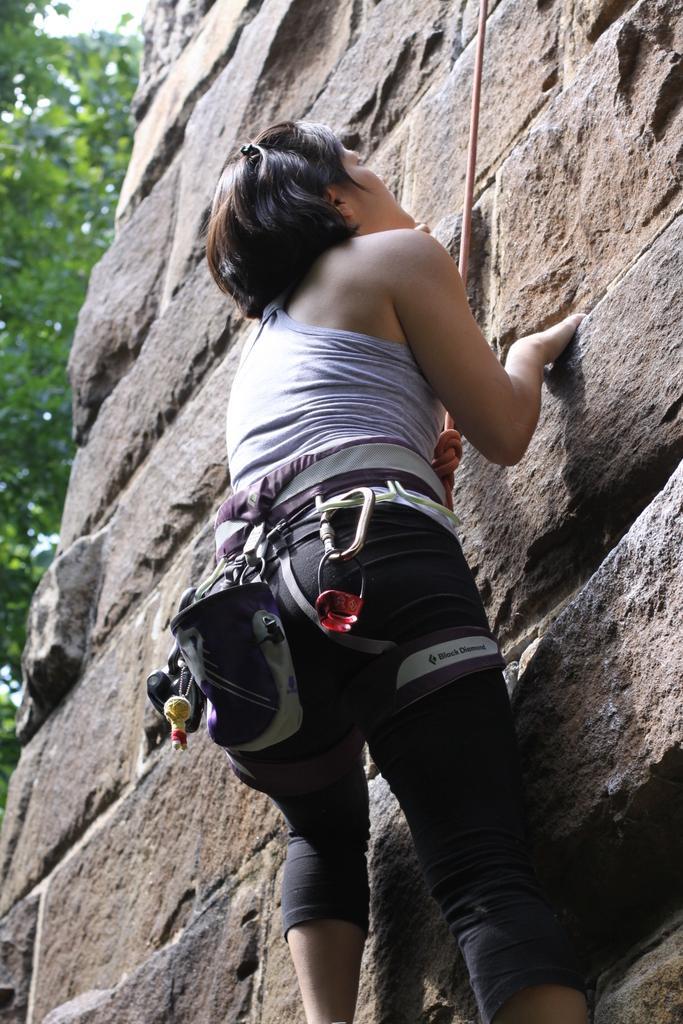Can you describe this image briefly? Here we can see a person climbing a wall. In the background we can see trees. 